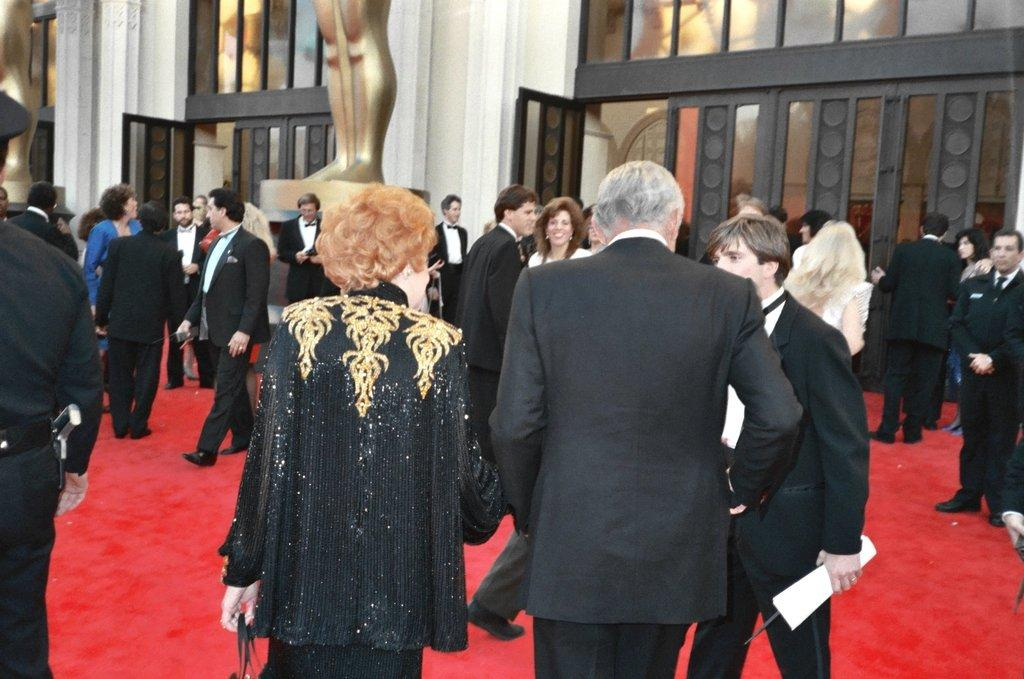How many people are in the image? There are many people in the image. What color are the dresses worn by most of the people? Most of the people are wearing black color dresses. What is at the bottom of the image? There is a red carpet at the bottom of the image. What can be seen in the background of the image? There is a door and walls visible in the background of the image. How many tickets are needed to enter the event in the image? There is no mention of an event or tickets in the image; it simply shows a group of people with a red carpet and a door in the background. 